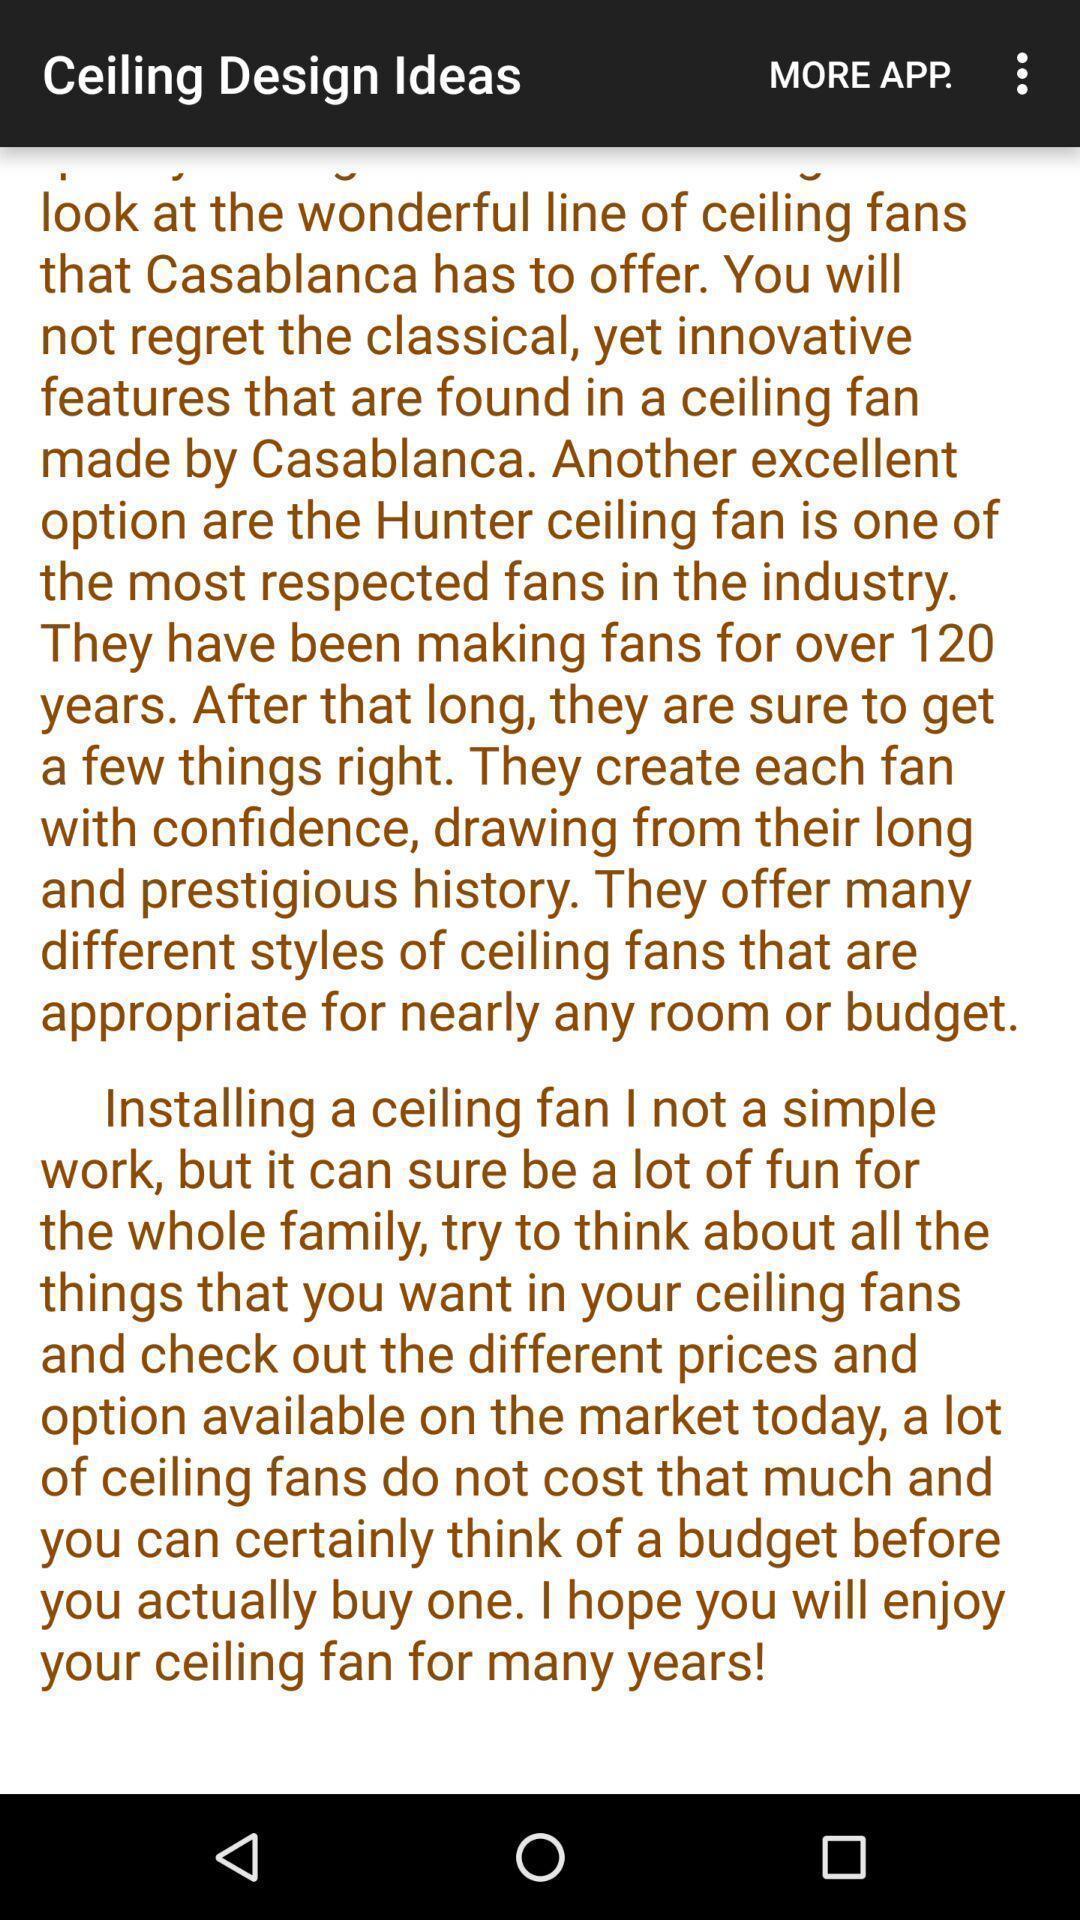Describe the key features of this screenshot. Page showing information for ceiling design ideas. 